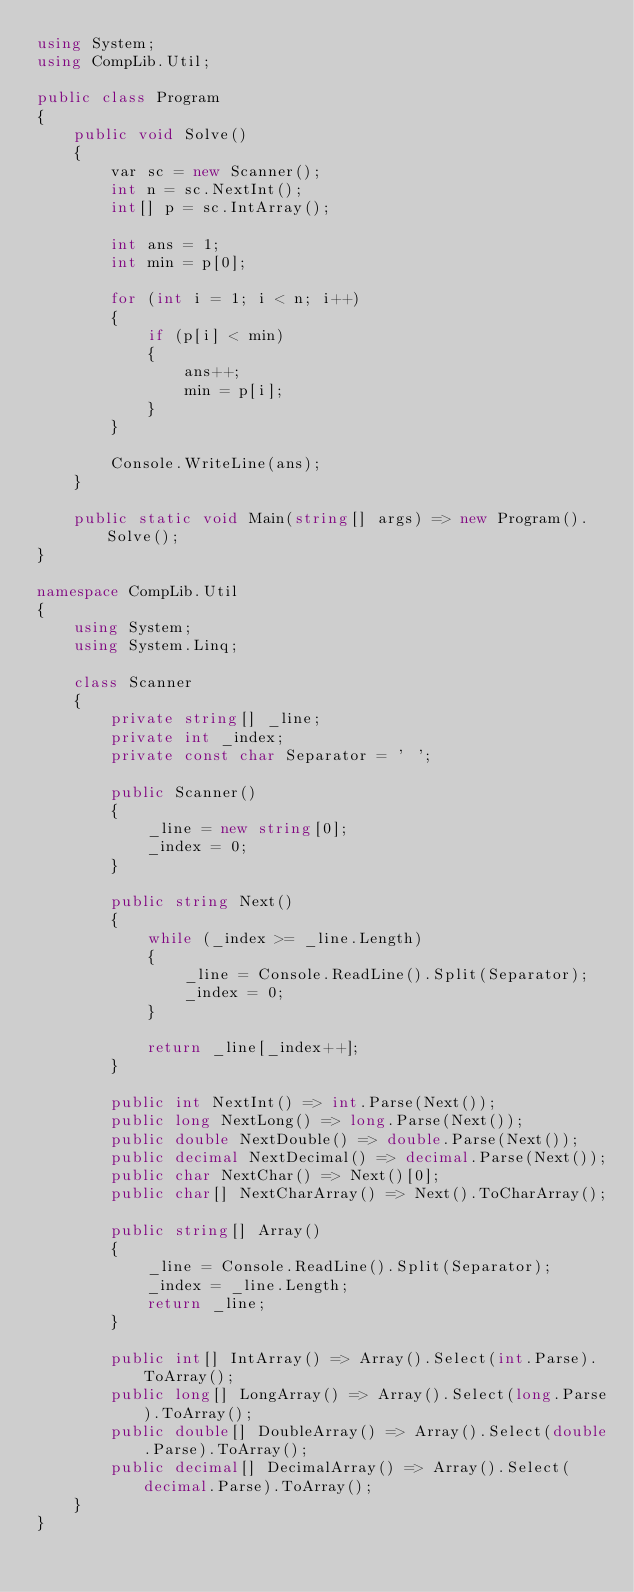<code> <loc_0><loc_0><loc_500><loc_500><_C#_>using System;
using CompLib.Util;

public class Program
{
    public void Solve()
    {
        var sc = new Scanner();
        int n = sc.NextInt();
        int[] p = sc.IntArray();

        int ans = 1;
        int min = p[0];

        for (int i = 1; i < n; i++)
        {
            if (p[i] < min)
            {
                ans++;
                min = p[i];
            }
        }

        Console.WriteLine(ans);
    }

    public static void Main(string[] args) => new Program().Solve();
}

namespace CompLib.Util
{
    using System;
    using System.Linq;

    class Scanner
    {
        private string[] _line;
        private int _index;
        private const char Separator = ' ';

        public Scanner()
        {
            _line = new string[0];
            _index = 0;
        }

        public string Next()
        {
            while (_index >= _line.Length)
            {
                _line = Console.ReadLine().Split(Separator);
                _index = 0;
            }

            return _line[_index++];
        }

        public int NextInt() => int.Parse(Next());
        public long NextLong() => long.Parse(Next());
        public double NextDouble() => double.Parse(Next());
        public decimal NextDecimal() => decimal.Parse(Next());
        public char NextChar() => Next()[0];
        public char[] NextCharArray() => Next().ToCharArray();

        public string[] Array()
        {
            _line = Console.ReadLine().Split(Separator);
            _index = _line.Length;
            return _line;
        }

        public int[] IntArray() => Array().Select(int.Parse).ToArray();
        public long[] LongArray() => Array().Select(long.Parse).ToArray();
        public double[] DoubleArray() => Array().Select(double.Parse).ToArray();
        public decimal[] DecimalArray() => Array().Select(decimal.Parse).ToArray();
    }
}</code> 